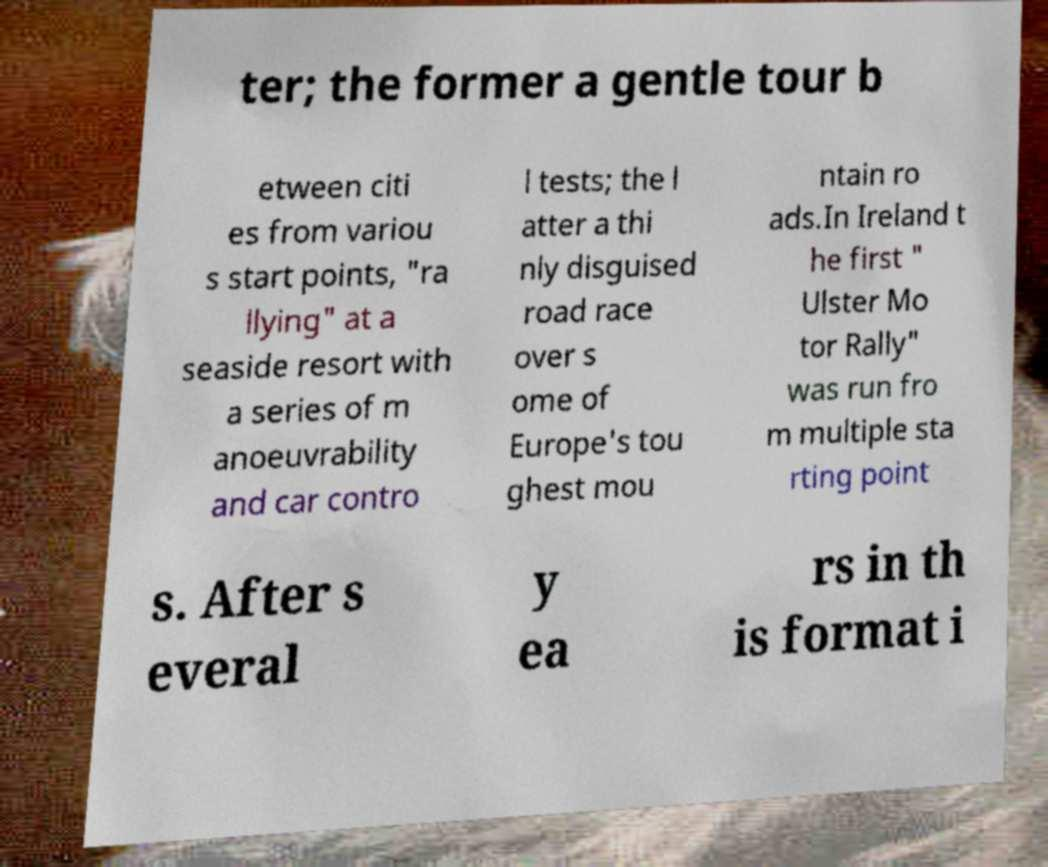What messages or text are displayed in this image? I need them in a readable, typed format. ter; the former a gentle tour b etween citi es from variou s start points, "ra llying" at a seaside resort with a series of m anoeuvrability and car contro l tests; the l atter a thi nly disguised road race over s ome of Europe's tou ghest mou ntain ro ads.In Ireland t he first " Ulster Mo tor Rally" was run fro m multiple sta rting point s. After s everal y ea rs in th is format i 